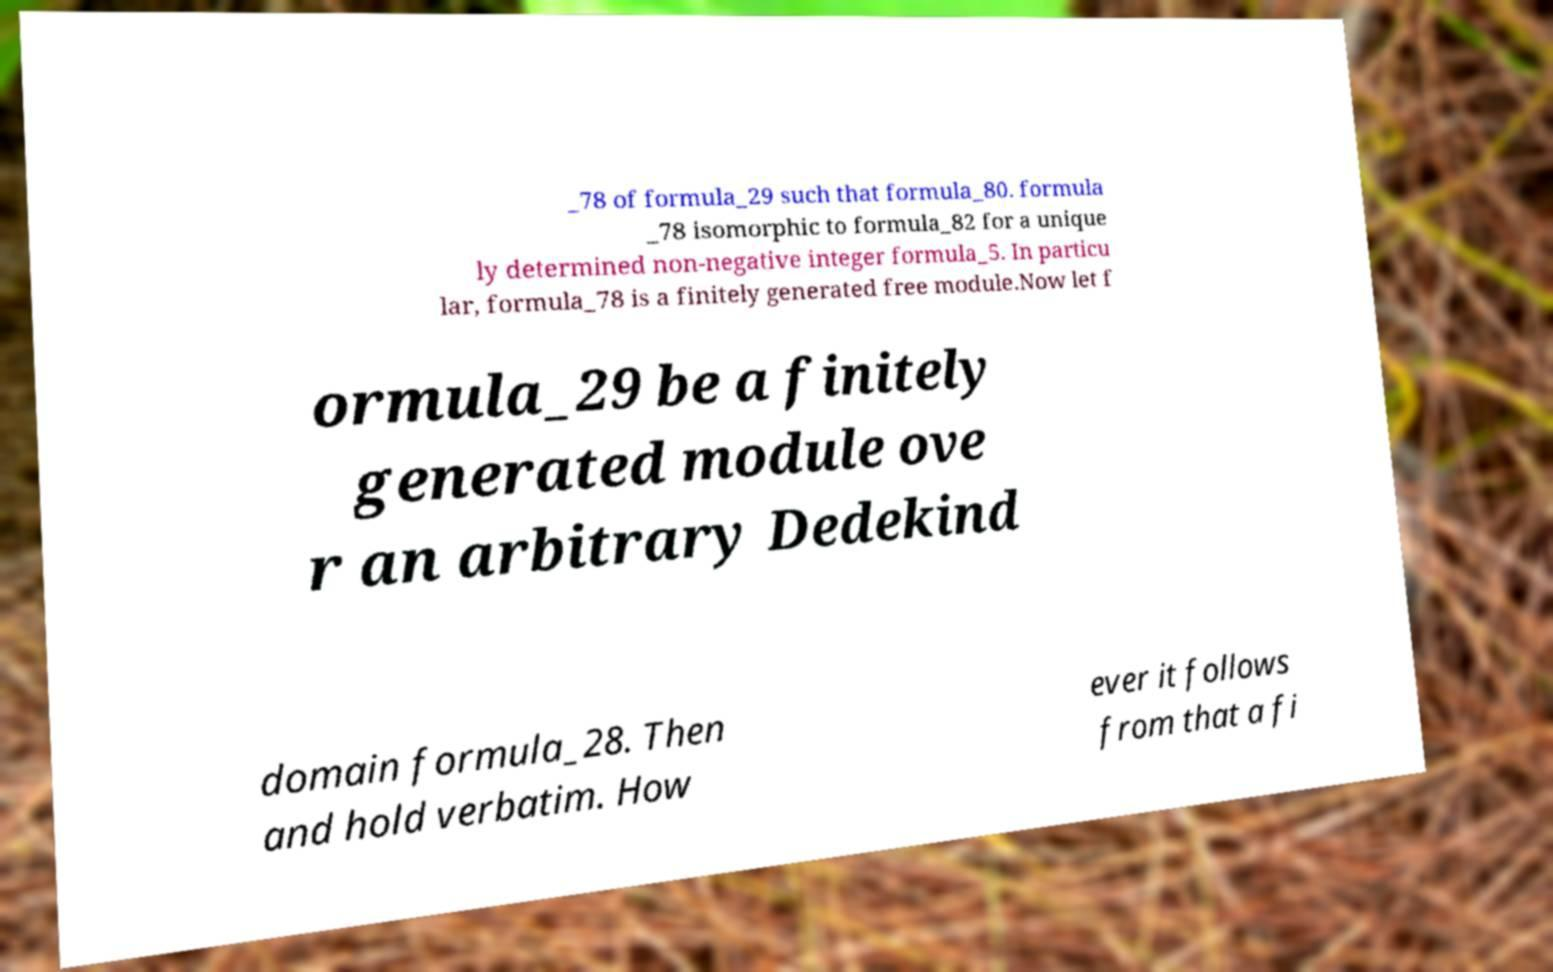Please identify and transcribe the text found in this image. _78 of formula_29 such that formula_80. formula _78 isomorphic to formula_82 for a unique ly determined non-negative integer formula_5. In particu lar, formula_78 is a finitely generated free module.Now let f ormula_29 be a finitely generated module ove r an arbitrary Dedekind domain formula_28. Then and hold verbatim. How ever it follows from that a fi 